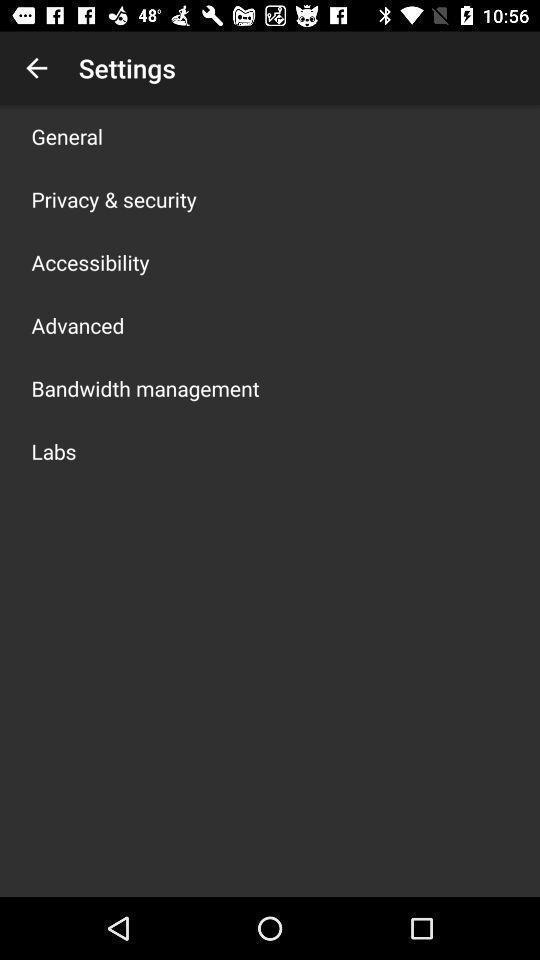Summarize the main components in this picture. Settings page. 